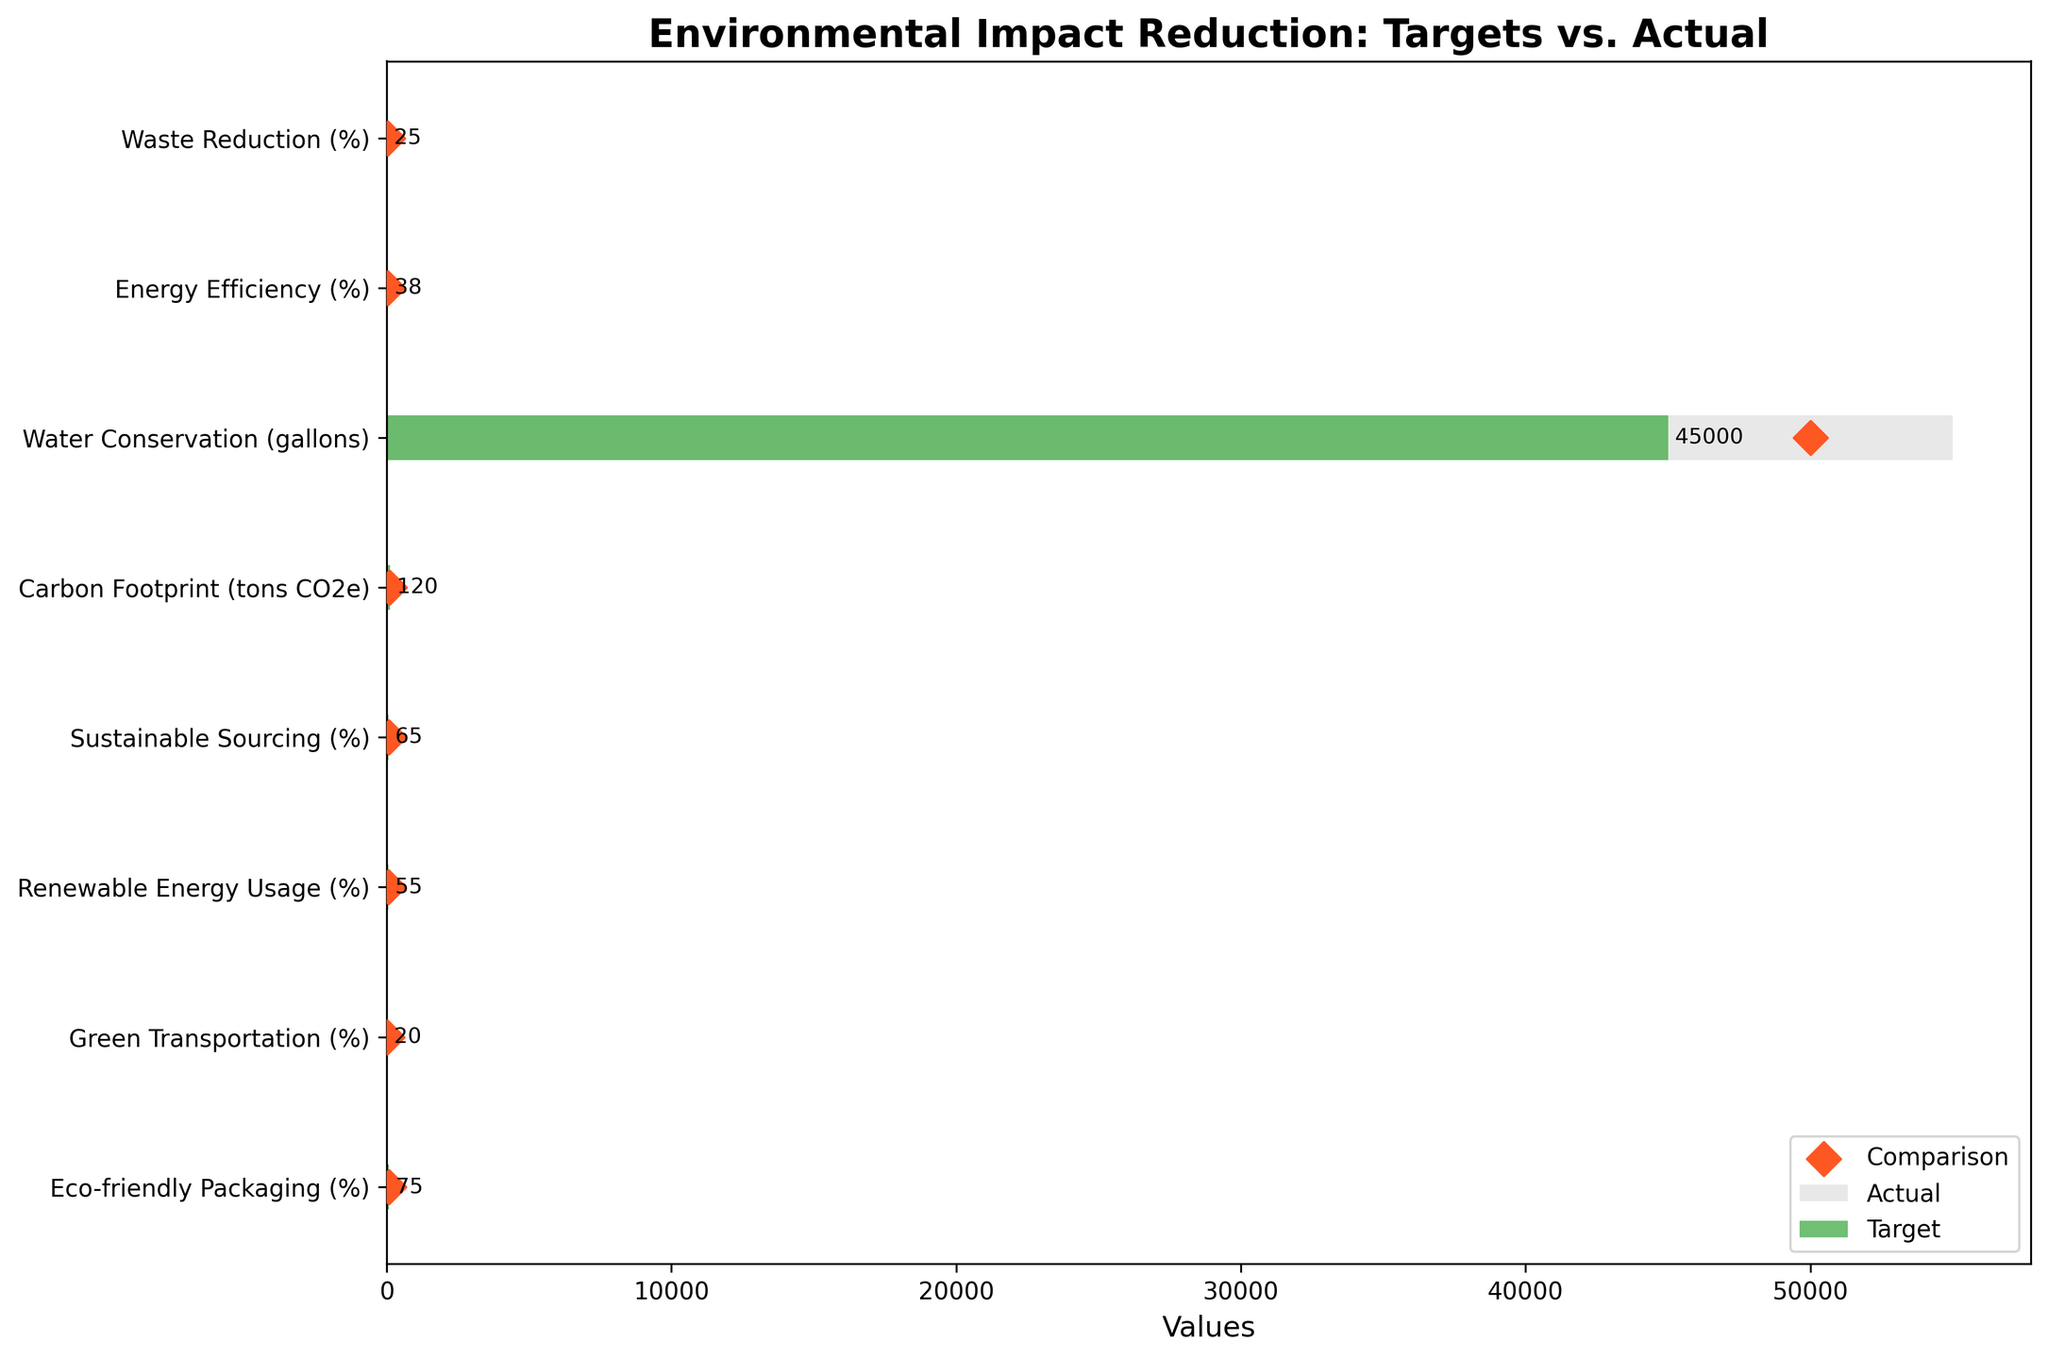What is the title of the figure? The title of the figure appears at the top and is often in bold to help viewers quickly understand the context of the chart.
Answer: Environmental Impact Reduction: Targets vs. Actual What are the labels on the y-axis? The labels on the y-axis represent the different sustainability measures being evaluated. These are listed along the left side of the chart.
Answer: Waste Reduction, Energy Efficiency, Water Conservation, Carbon Footprint, Sustainable Sourcing, Renewable Energy Usage, Green Transportation, Eco-friendly Packaging What color represents the 'Actual' values in the chart? The color representing the 'Actual' values is often distinct to differentiate it from other values. In this chart, the 'Actual' values are represented by the color green.
Answer: Green Which sustainability measure has the largest difference between its actual value and its target value? To find the measure with the largest difference, we need to compare the difference between the actual and target values for each measure. The measure with the largest negative difference shows a greater shortfall.
Answer: Carbon Footprint Is the target for water conservation met? To determine if the target is met, we compare the actual value to the target value. If the actual value is equal to or higher than the target, the target is met. In this case, the actual value is lower than the target.
Answer: No How much more did the actual value for green transportation exceed its target value? To find the excess, subtract the target value from the actual value for green transportation. We get 30 - 25 = 5.
Answer: 5 Which measure has an actual value closest to its target value? Calculate the absolute difference between the actual and target values for each measure. The measure with the smallest difference is the one where the actual value is closest to the target value.
Answer: Energy Efficiency By how much did sustainable sourcing fall short of its target? Subtract the actual value from the target value for sustainable sourcing. We get 70 - 65 = 5.
Answer: 5 How many sustainability measures exceeded their comparison value? Count the number of measures where the actual value is greater than the comparison value. Visually, these are measures where the green bar extends beyond the light grey bar.
Answer: 5 Which measure achieved the highest actual value compared to its target in percentage terms? Calculate the percentage of the target achieved by each actual value: (Actual/Target)*100. The measure with the highest percentage is the one that most significantly exceeded its target.
Answer: Renewable Energy Usage 